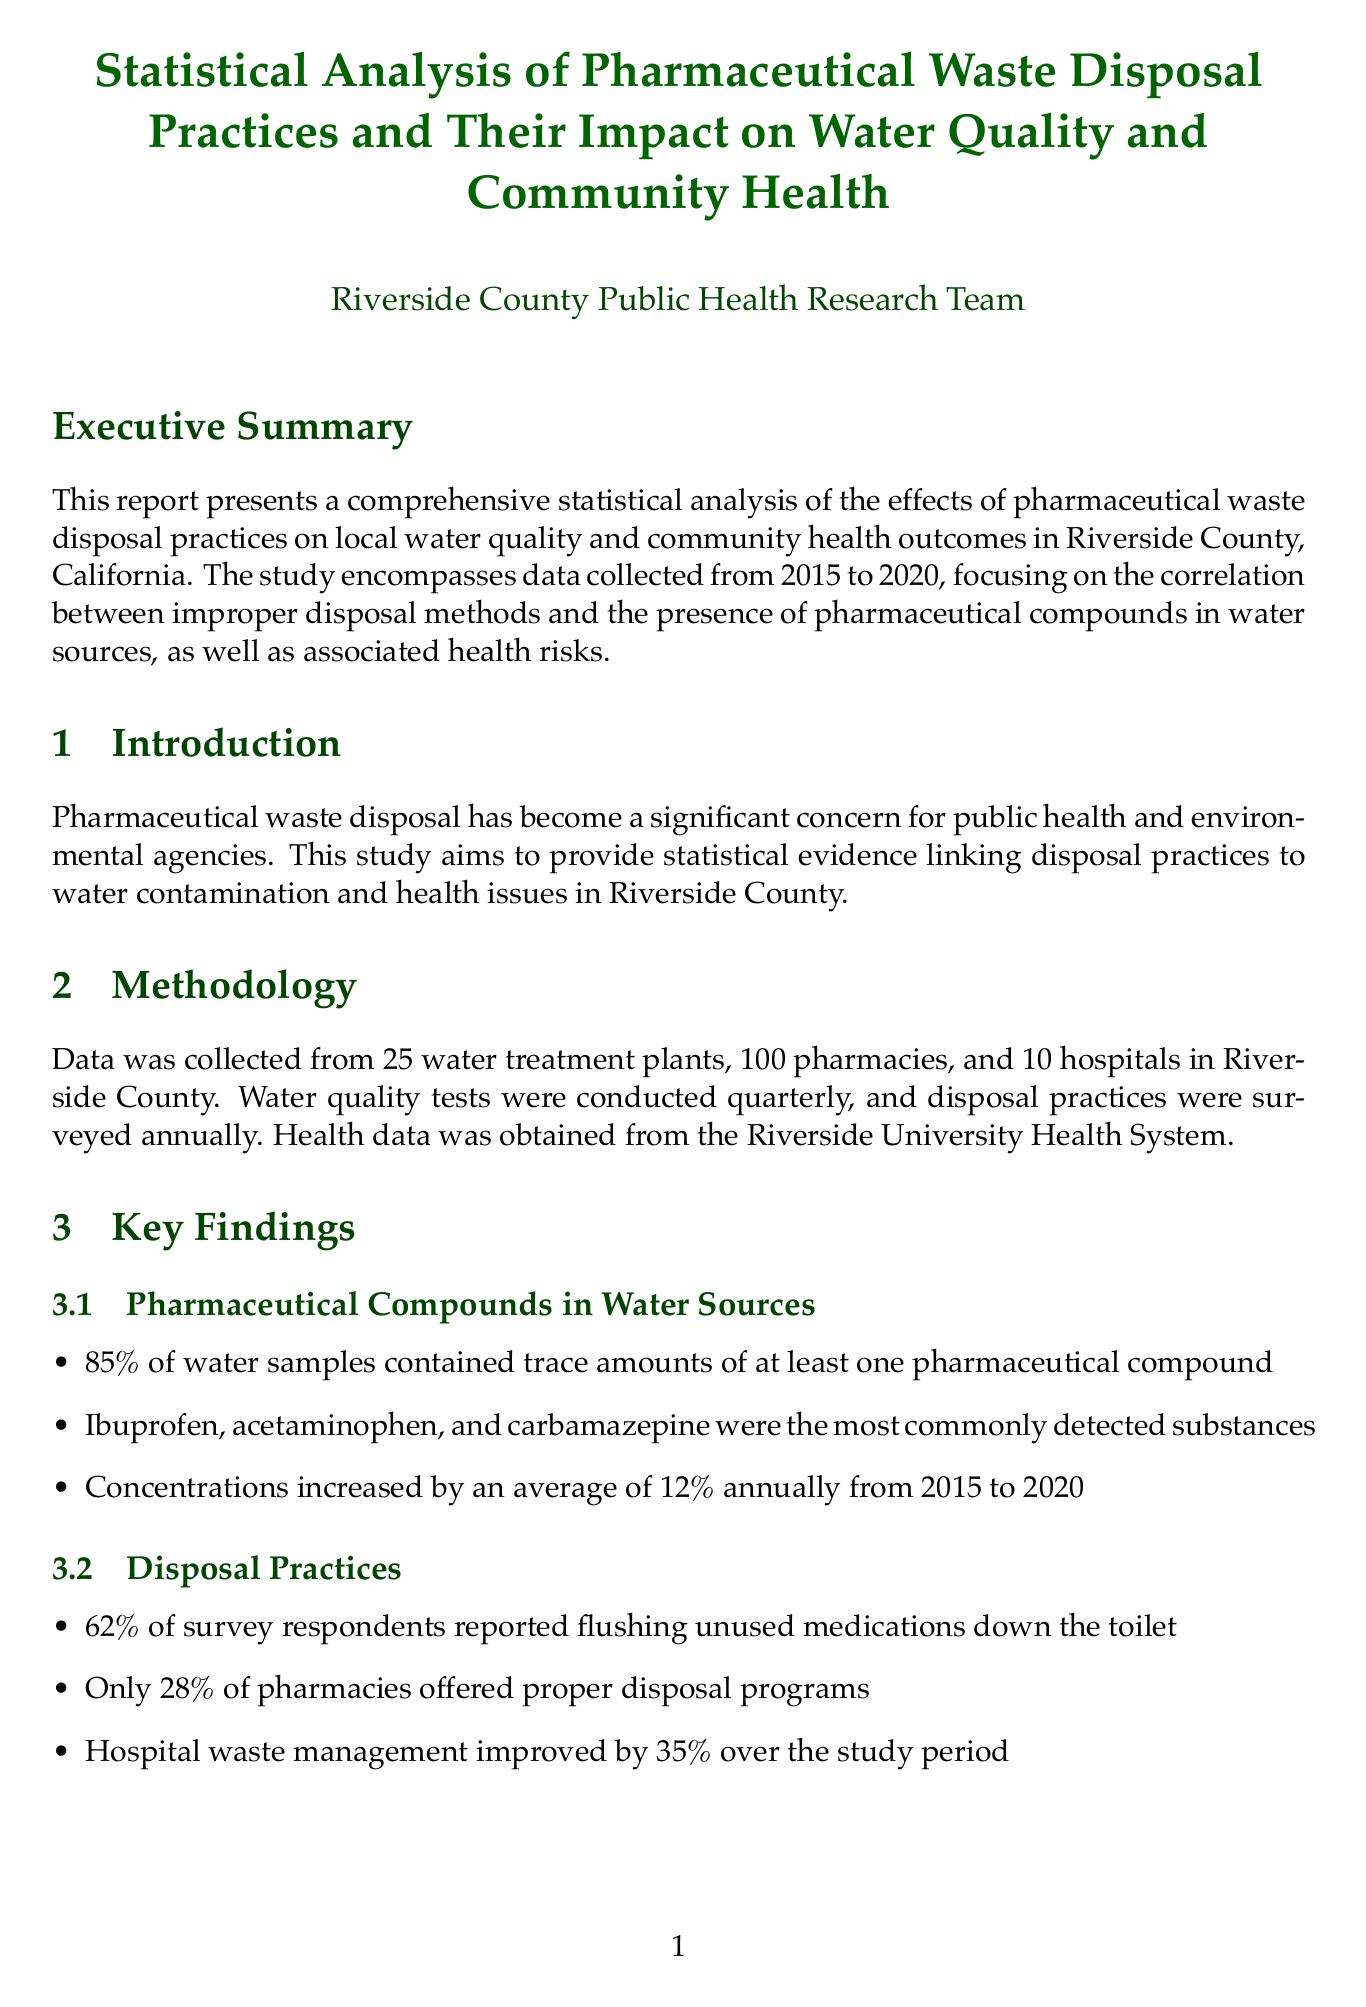what is the report title? The report title is stated at the beginning of the document.
Answer: Statistical Analysis of Pharmaceutical Waste Disposal Practices and Their Impact on Water Quality and Community Health how many pharmacies were surveyed? The document specifies that data was collected from a certain number of pharmacies.
Answer: 100 pharmacies what percentage of water samples contained pharmaceutical compounds? The key findings section provides this statistic regarding water samples.
Answer: 85% which pharmaceutical compound had the highest detection rate? The key findings mention the most commonly detected substances in water sources.
Answer: Ibuprofen what was the increase in reported cases of endocrine disruption disorders? This figure is found in the health impacts subsection of the key findings.
Answer: 23% what statistical analysis was performed to study the relationship between disposal practices and water contamination? The methodology section mentions the analysis type used for this investigation.
Answer: Multiple regression analysis which document highlights legal implications? The section dedicated to legal aspects addresses this concern in the report.
Answer: Legal Implications who conducted the analysis of pharmaceutical compounds in water samples? The expert consultations section identifies the contributing expert for this analysis.
Answer: Dr. Emily Chen 